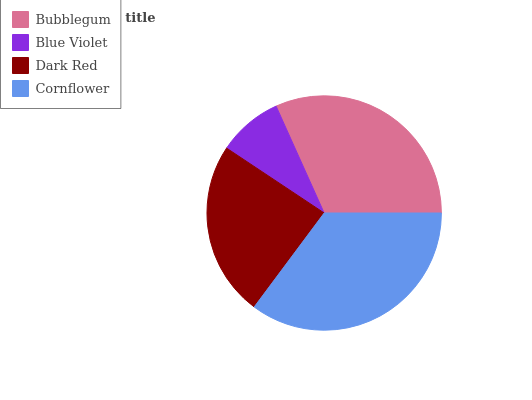Is Blue Violet the minimum?
Answer yes or no. Yes. Is Cornflower the maximum?
Answer yes or no. Yes. Is Dark Red the minimum?
Answer yes or no. No. Is Dark Red the maximum?
Answer yes or no. No. Is Dark Red greater than Blue Violet?
Answer yes or no. Yes. Is Blue Violet less than Dark Red?
Answer yes or no. Yes. Is Blue Violet greater than Dark Red?
Answer yes or no. No. Is Dark Red less than Blue Violet?
Answer yes or no. No. Is Bubblegum the high median?
Answer yes or no. Yes. Is Dark Red the low median?
Answer yes or no. Yes. Is Blue Violet the high median?
Answer yes or no. No. Is Cornflower the low median?
Answer yes or no. No. 